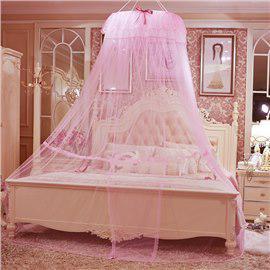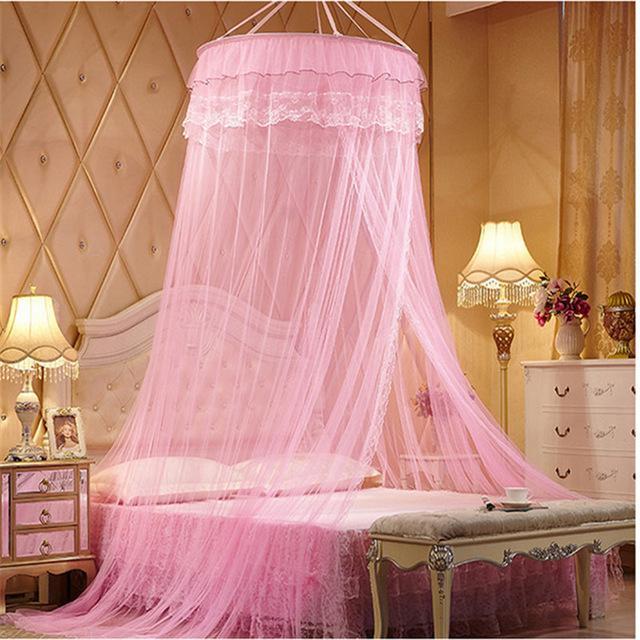The first image is the image on the left, the second image is the image on the right. Given the left and right images, does the statement "All curtains displayed are pink or red and hung from a circular shaped rod directly above the bed." hold true? Answer yes or no. Yes. The first image is the image on the left, the second image is the image on the right. For the images shown, is this caption "The left bed is covered by a square drape, the right bed by a round drape." true? Answer yes or no. No. 